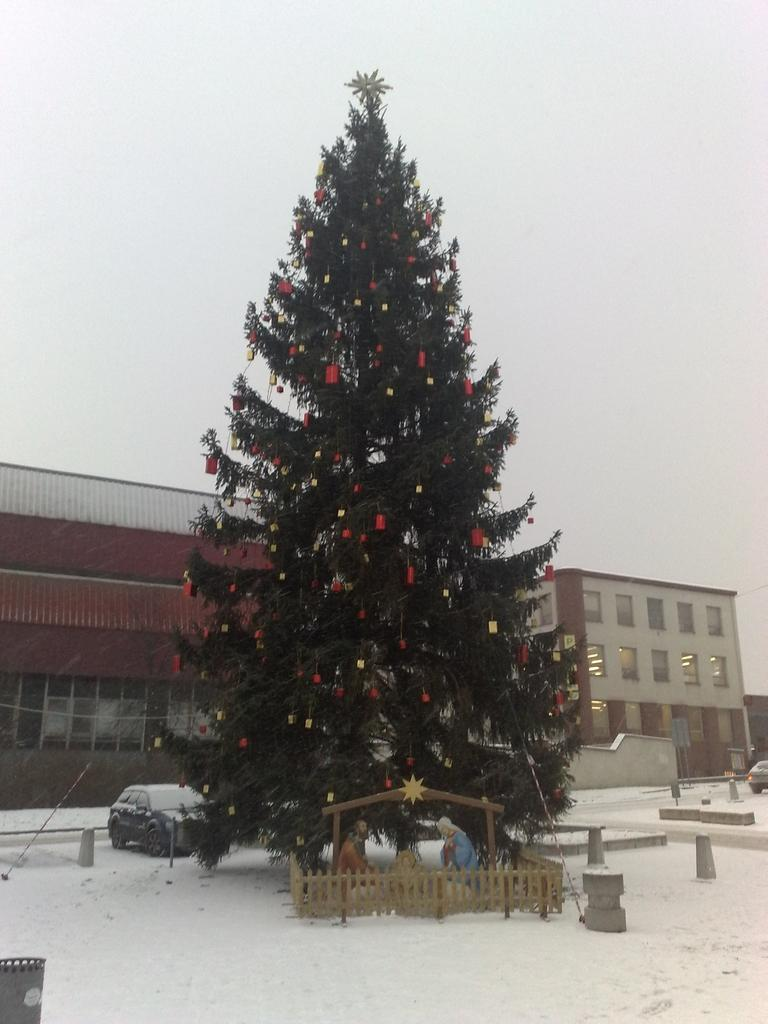What is the main subject in the center of the image? There is a Christmas tree in the center of the image. What is the surface on which the Christmas tree is placed? The Christmas tree is on the snow. What can be seen in the background of the image? There are vehicles and buildings in the background of the image, as well as the sky. What type of book is the person reading in the image? There is no person reading a book in the image; it features a Christmas tree on the snow with vehicles, buildings, and the sky in the background. 